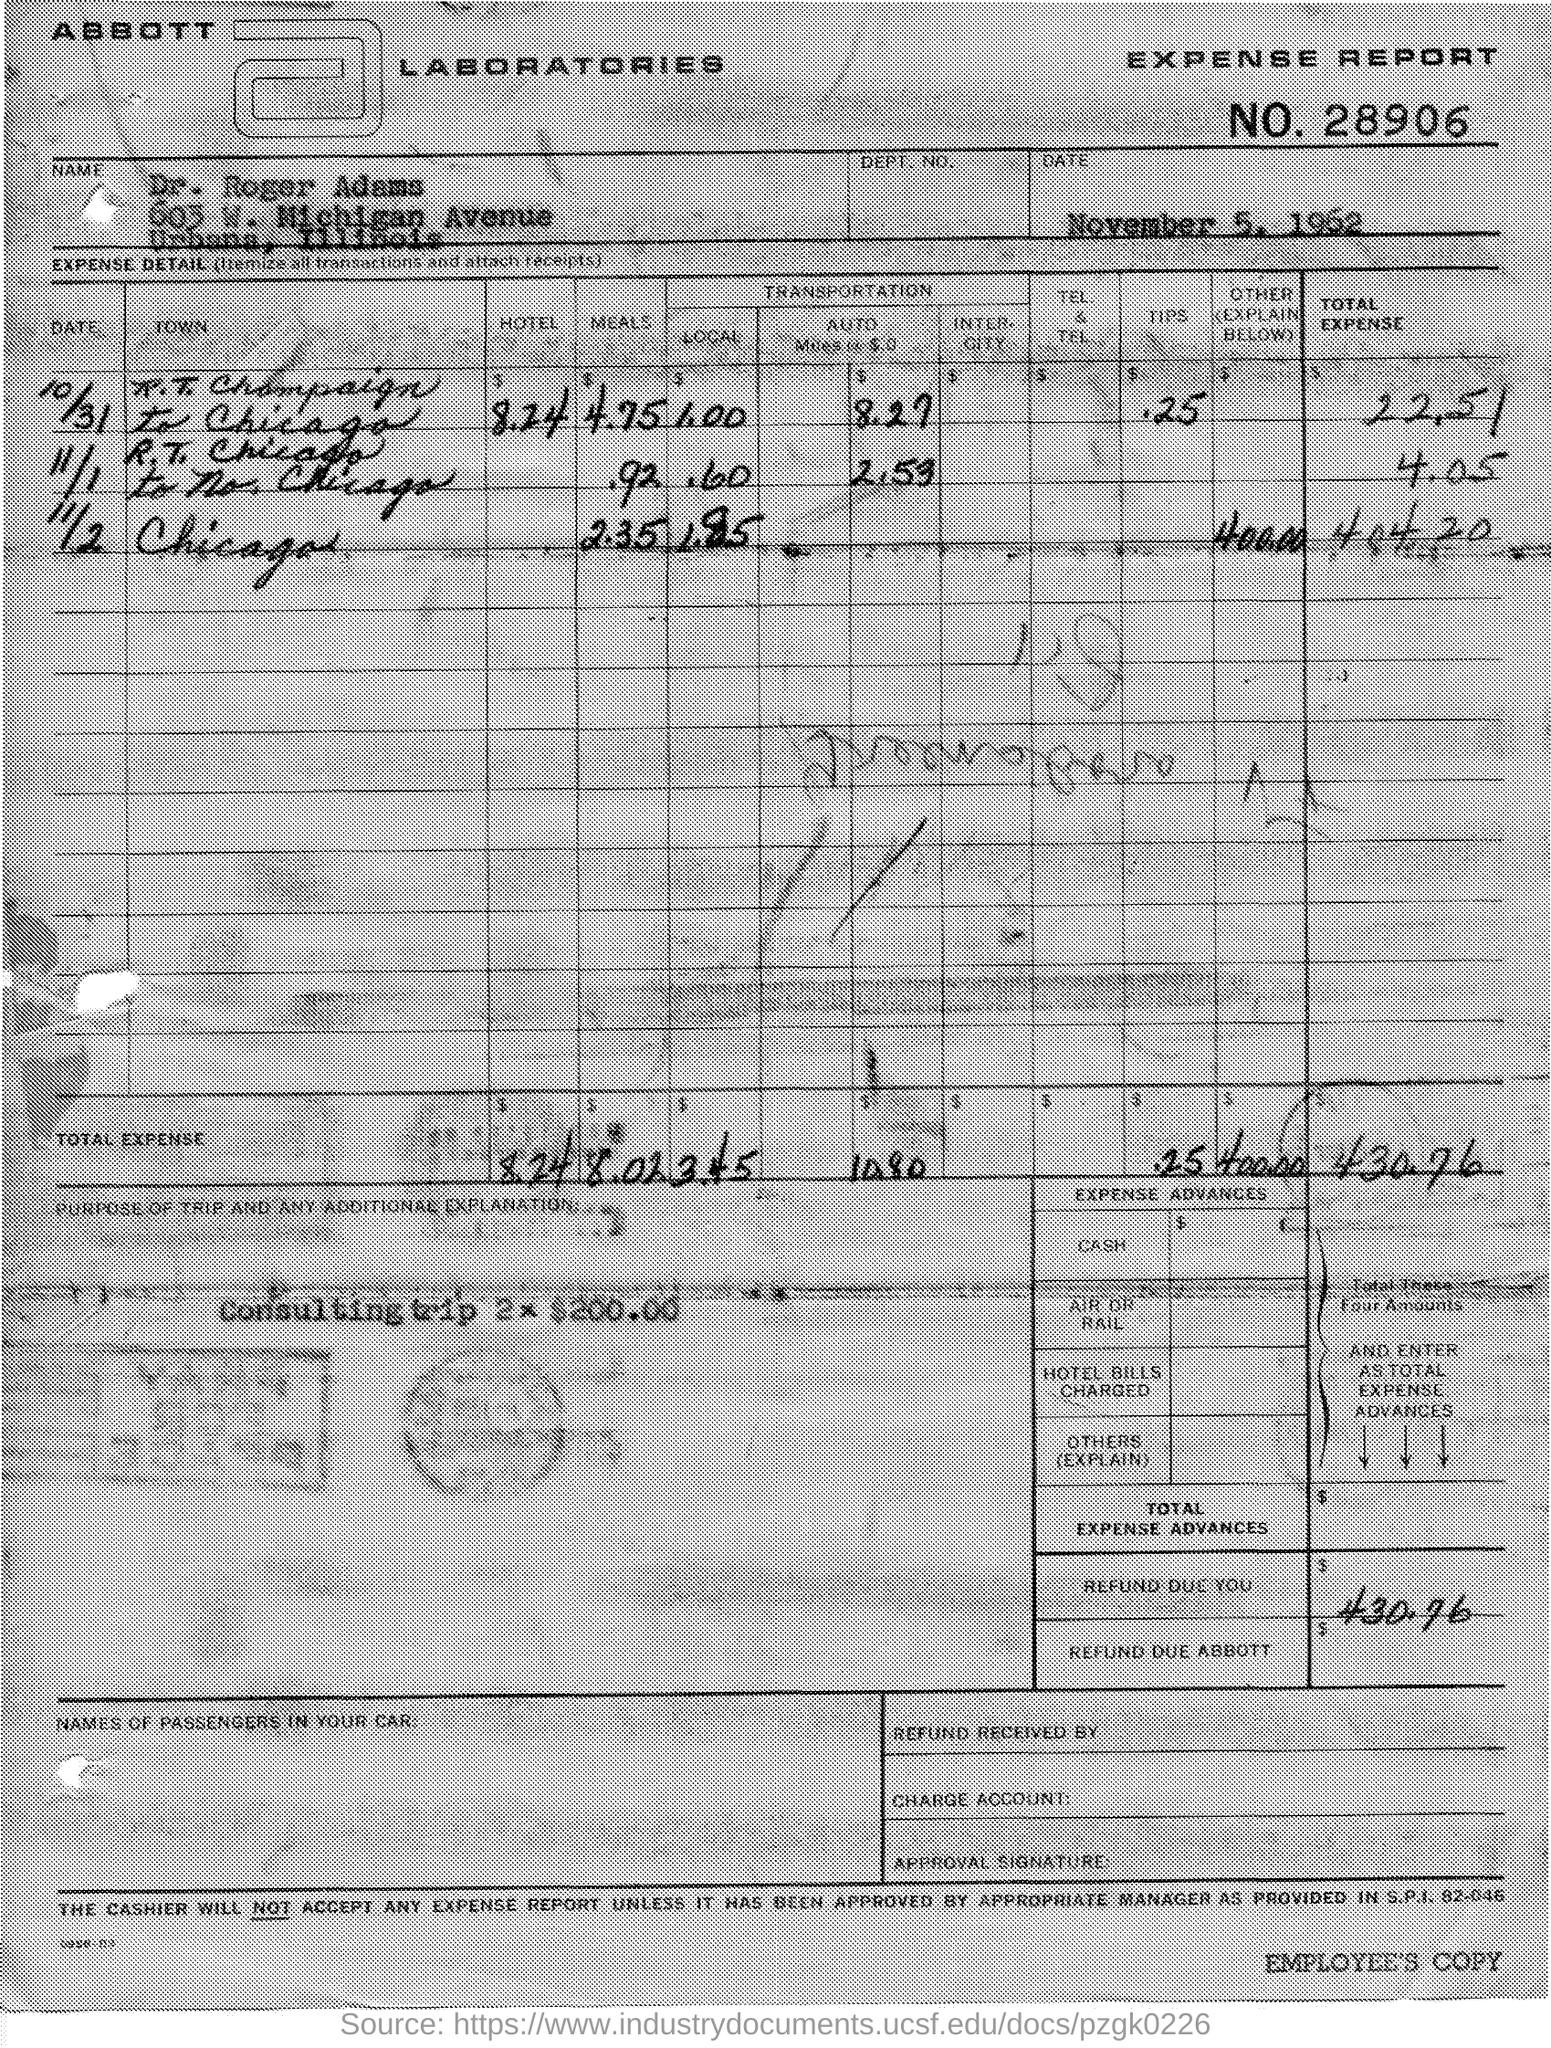Draw attention to some important aspects in this diagram. R.T. Chicago made a trip to No. Chicago on November 1st. The expense details belonged to Dr. Roger Adams. Four hundred and thirty dollars and seventy-six cents were refunded. The expenses for the Chicago trip on November 2 are estimated to be 400. What is the expense report number? 